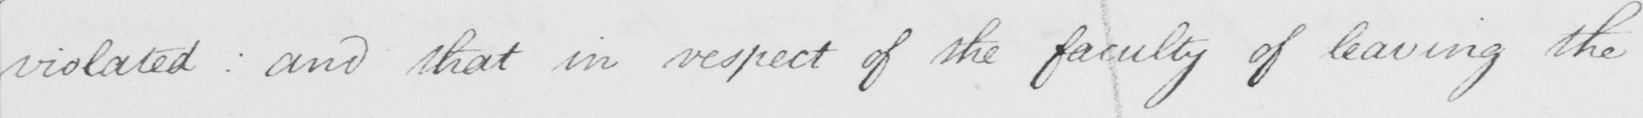Please transcribe the handwritten text in this image. violated :  and that in respect of the faculty of leaving the 